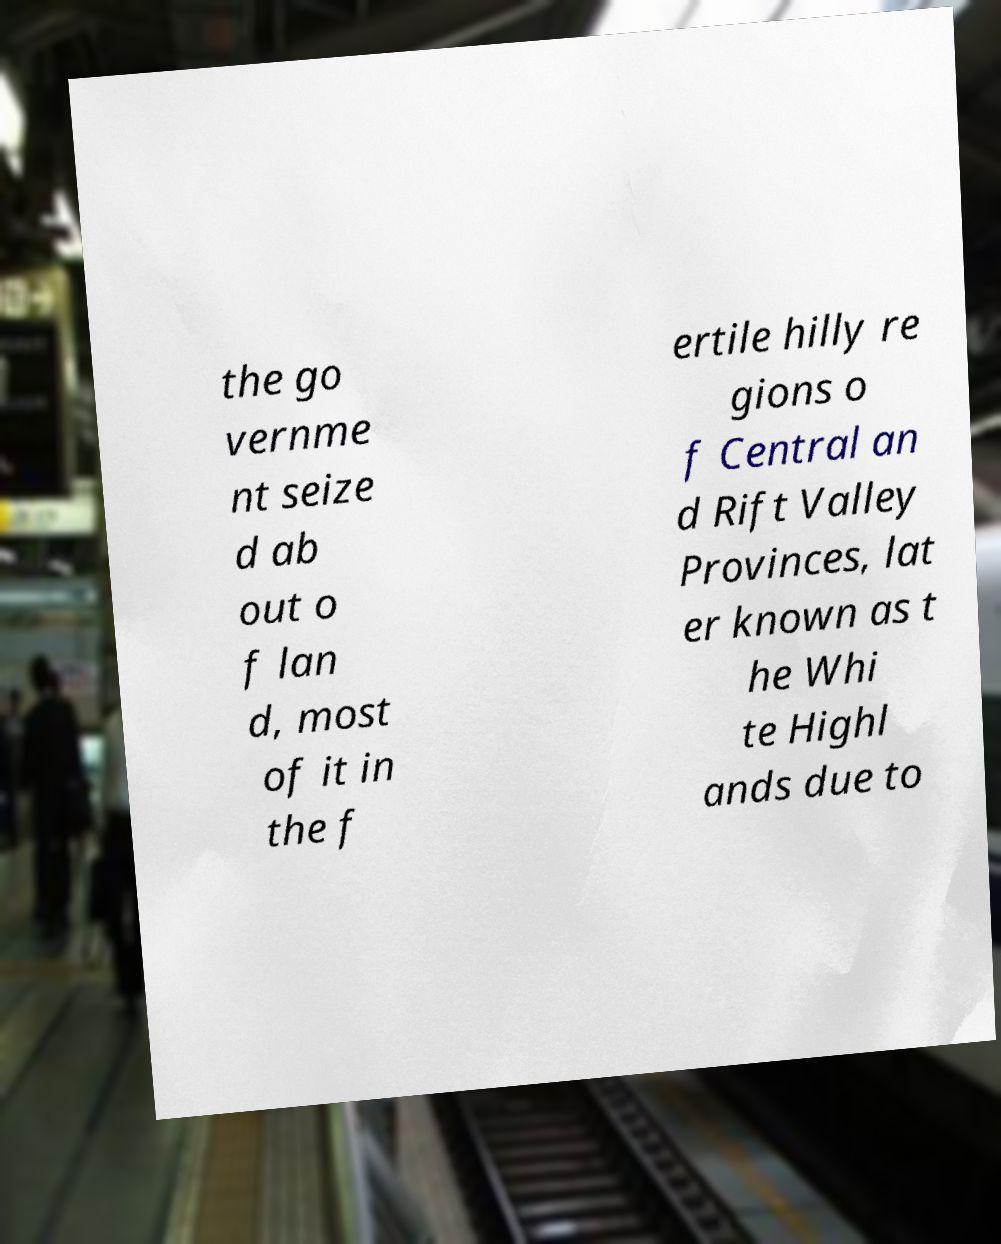I need the written content from this picture converted into text. Can you do that? the go vernme nt seize d ab out o f lan d, most of it in the f ertile hilly re gions o f Central an d Rift Valley Provinces, lat er known as t he Whi te Highl ands due to 